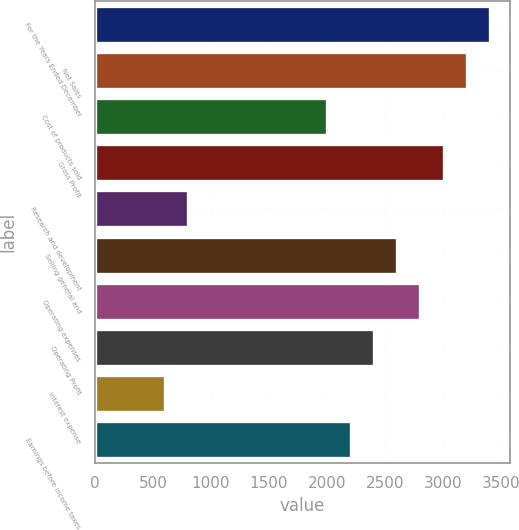Convert chart. <chart><loc_0><loc_0><loc_500><loc_500><bar_chart><fcel>For the Years Ended December<fcel>Net Sales<fcel>Cost of products sold<fcel>Gross Profit<fcel>Research and development<fcel>Selling general and<fcel>Operating expenses<fcel>Operating Profit<fcel>Interest expense<fcel>Earnings before income taxes<nl><fcel>3402.5<fcel>3202.43<fcel>2002.01<fcel>3002.36<fcel>801.59<fcel>2602.22<fcel>2802.29<fcel>2402.15<fcel>601.52<fcel>2202.08<nl></chart> 